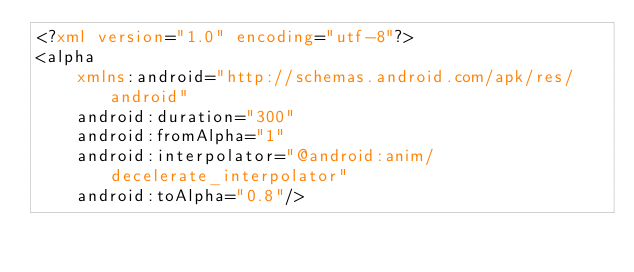<code> <loc_0><loc_0><loc_500><loc_500><_XML_><?xml version="1.0" encoding="utf-8"?>
<alpha
    xmlns:android="http://schemas.android.com/apk/res/android"
    android:duration="300"
    android:fromAlpha="1"
    android:interpolator="@android:anim/decelerate_interpolator"
    android:toAlpha="0.8"/>
</code> 